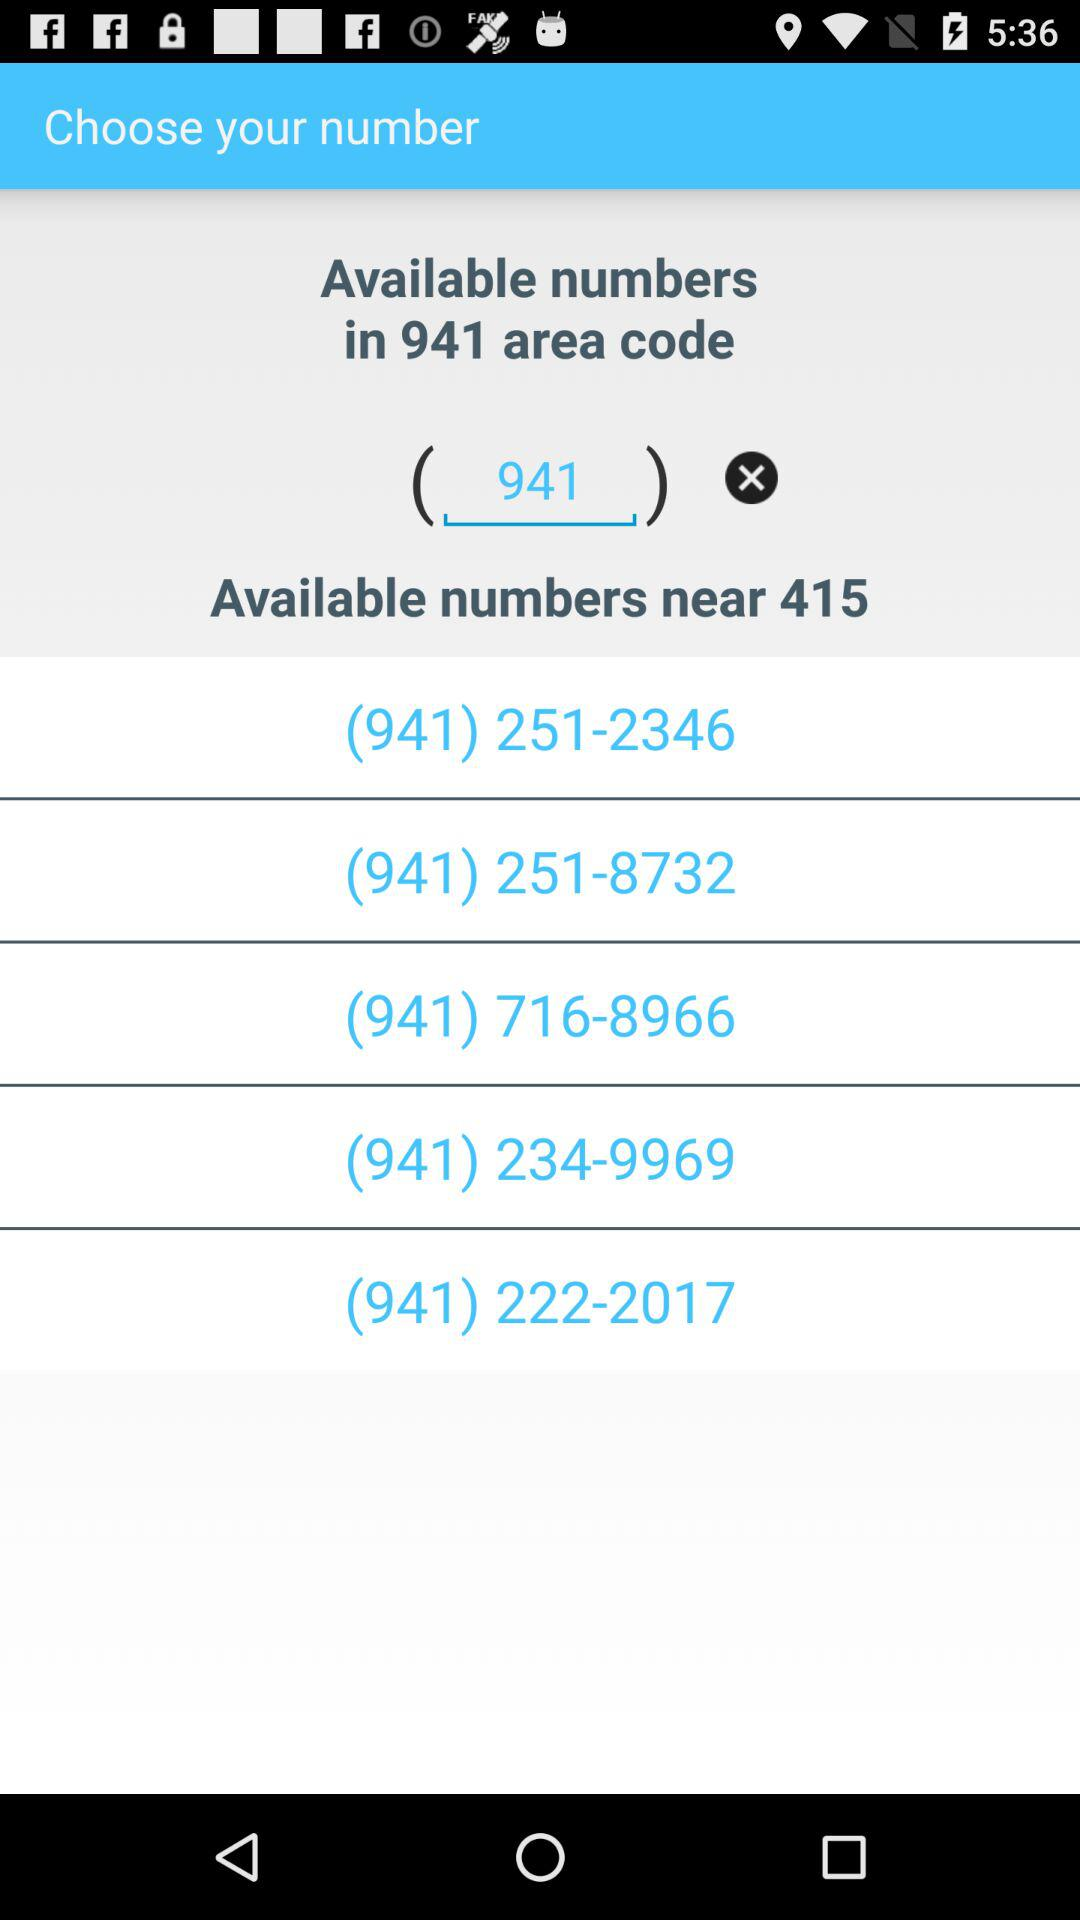What is the area code? The area code is 941. 